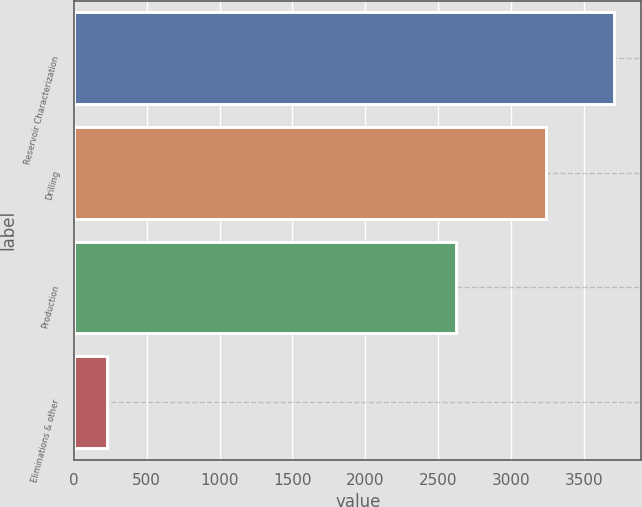<chart> <loc_0><loc_0><loc_500><loc_500><bar_chart><fcel>Reservoir Characterization<fcel>Drilling<fcel>Production<fcel>Eliminations & other<nl><fcel>3711<fcel>3238<fcel>2624<fcel>229<nl></chart> 